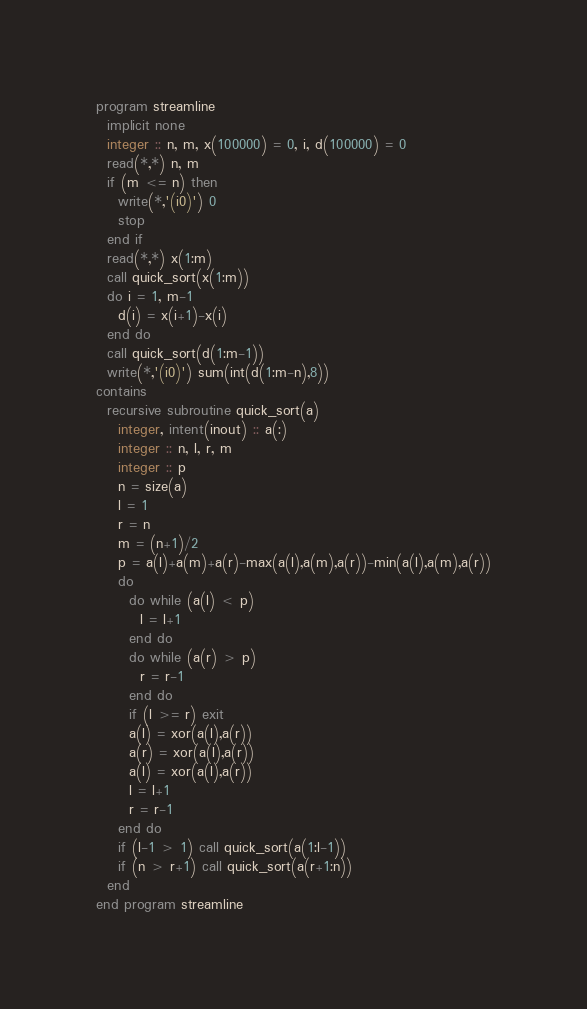Convert code to text. <code><loc_0><loc_0><loc_500><loc_500><_FORTRAN_>program streamline
  implicit none
  integer :: n, m, x(100000) = 0, i, d(100000) = 0
  read(*,*) n, m
  if (m <= n) then
    write(*,'(i0)') 0
    stop
  end if
  read(*,*) x(1:m)
  call quick_sort(x(1:m))
  do i = 1, m-1
    d(i) = x(i+1)-x(i)
  end do
  call quick_sort(d(1:m-1))
  write(*,'(i0)') sum(int(d(1:m-n),8))
contains
  recursive subroutine quick_sort(a)
    integer, intent(inout) :: a(:)
    integer :: n, l, r, m
    integer :: p
    n = size(a)
    l = 1
    r = n
    m = (n+1)/2
    p = a(l)+a(m)+a(r)-max(a(l),a(m),a(r))-min(a(l),a(m),a(r))
    do
      do while (a(l) < p)
        l = l+1
      end do
      do while (a(r) > p)
        r = r-1
      end do
      if (l >= r) exit
      a(l) = xor(a(l),a(r))
      a(r) = xor(a(l),a(r))
      a(l) = xor(a(l),a(r))
      l = l+1
      r = r-1
    end do
    if (l-1 > 1) call quick_sort(a(1:l-1))
    if (n > r+1) call quick_sort(a(r+1:n))
  end
end program streamline</code> 